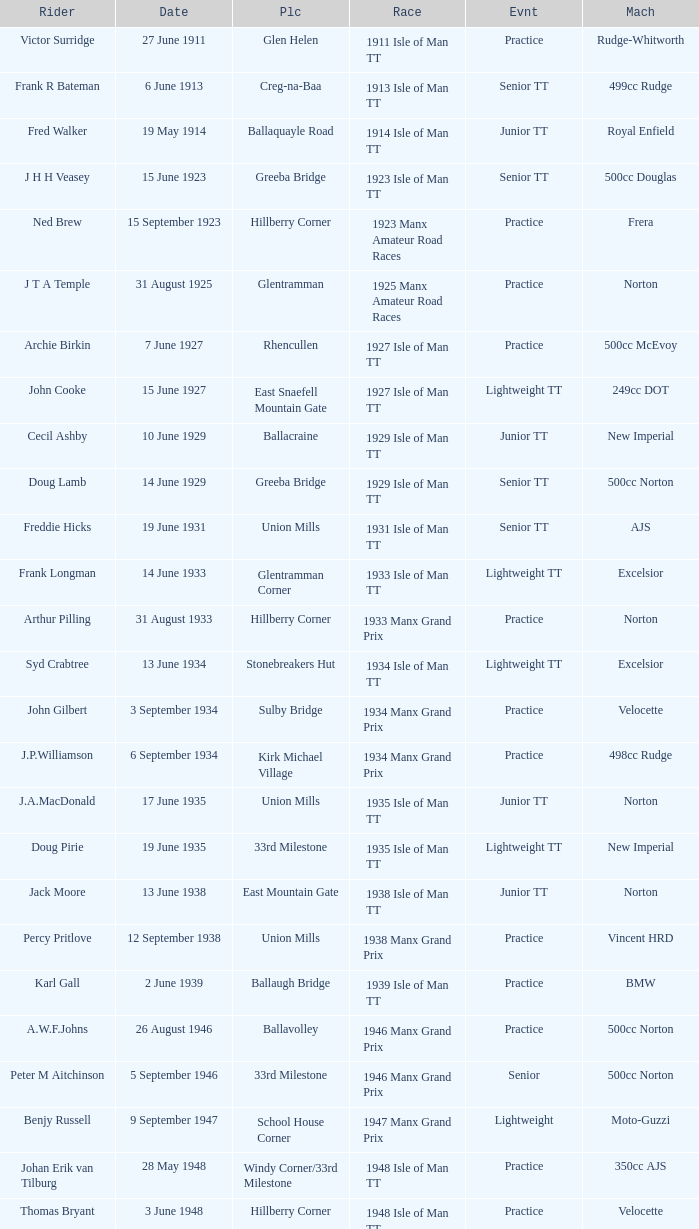Where was the 249cc Yamaha? Glentramman. 